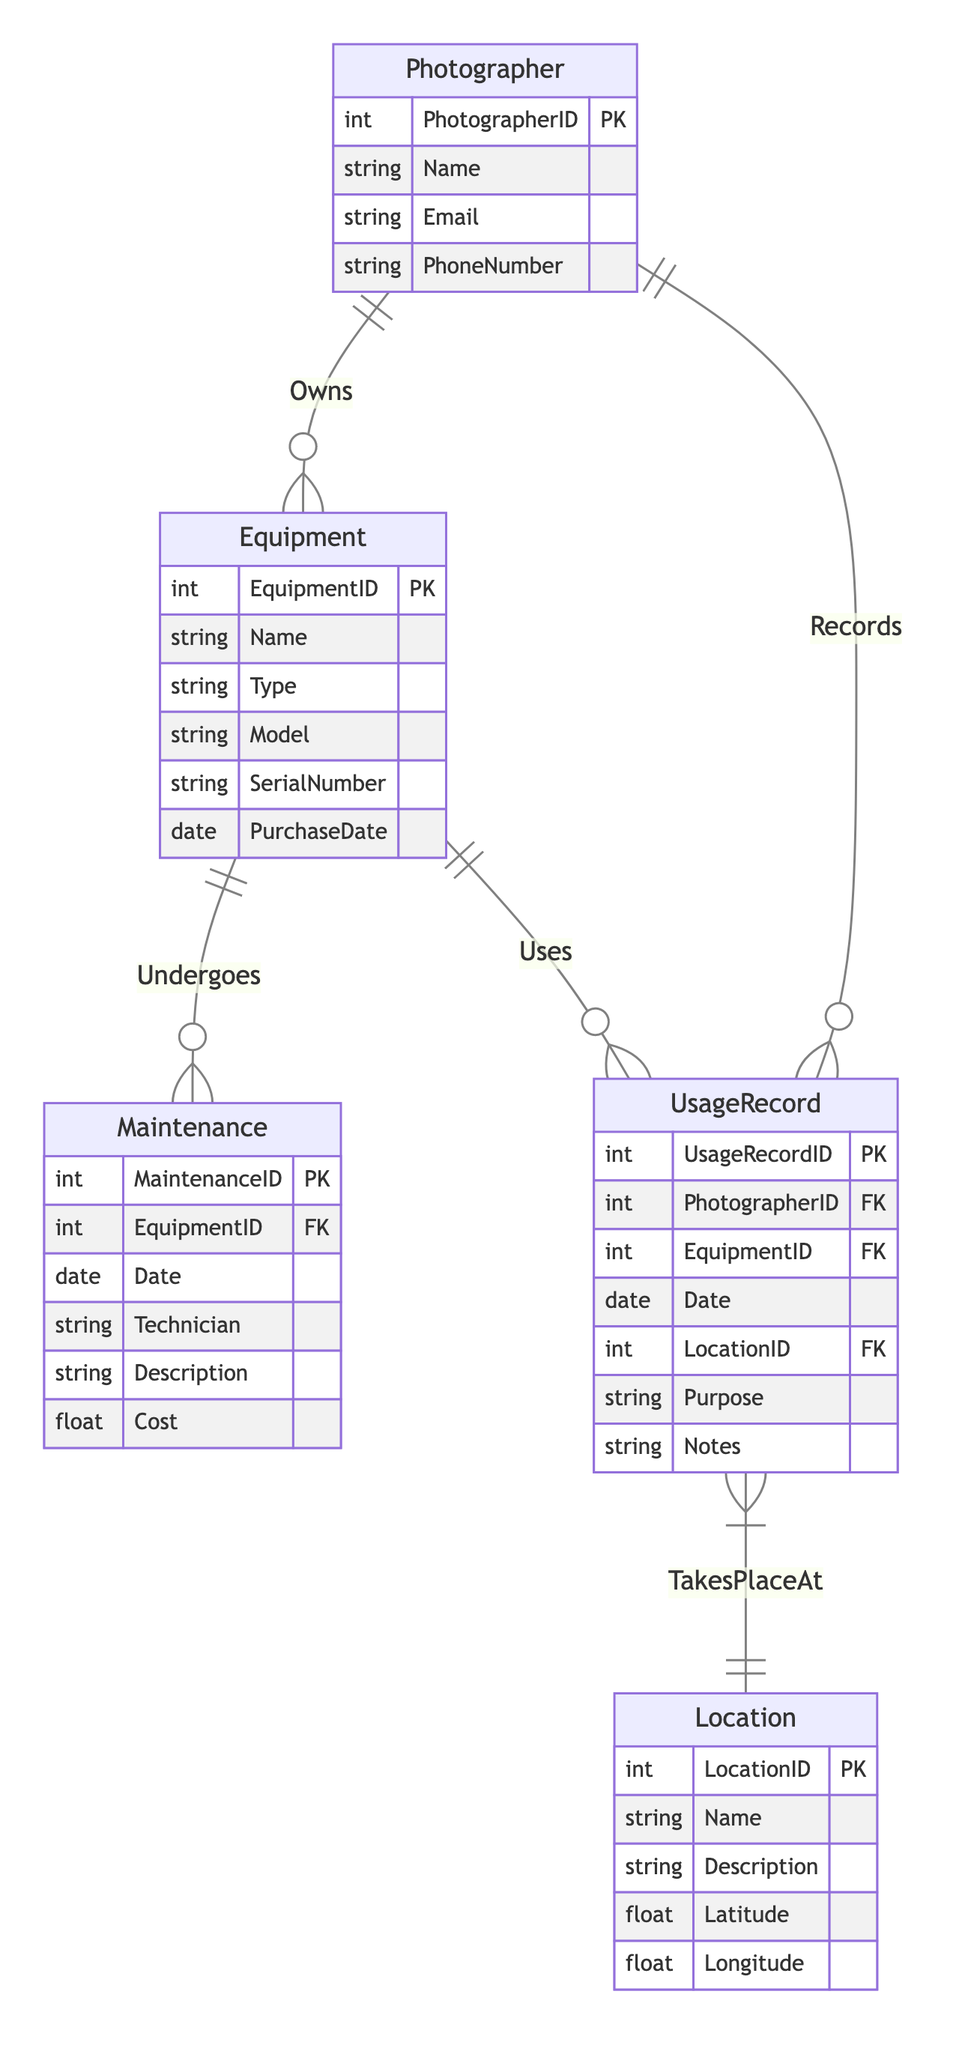What is the primary key of the Equipment entity? The primary key of the Equipment entity is EquipmentID, which is indicated by "PK" next to the attribute in the diagram.
Answer: EquipmentID How many relationships does the Photographer entity have? The Photographer entity has three relationships indicated in the diagram: Owns (with Equipment), Records (with UsageRecord), and Uses (with UsageRecord), totaling three relationships.
Answer: 3 What type of relationship exists between Equipment and Maintenance? The relationship between Equipment and Maintenance is "1:N," meaning that one piece of Equipment can undergo multiple Maintenance records. This is indicated in the diagram through the notation connecting the two entities.
Answer: 1:N How many total attributes does the Maintenance entity have? The Maintenance entity has six attributes, as listed in the diagram: MaintenanceID, EquipmentID, Date, Technician, Description, and Cost. Counting these gives a total of six attributes.
Answer: 6 What does the UsageRecord entity track in relation to the Photographer? The UsageRecord entity tracks the records made by the Photographer, including details such as Date, Purpose, and Notes. It reflects the relationship indicated by "Records" and serves to document usage details.
Answer: Records What is the cardinality of the relationship between UsageRecord and Location? The relationship between UsageRecord and Location is "1:N," signifying that one usage record can take place at one location, but one location can be associated with multiple usage records. This is shown by the notation in the diagram.
Answer: 1:N Which attribute in the UsageRecord entity identifies the purpose of using the equipment? The attribute that identifies the purpose of using the equipment in the UsageRecord entity is "Purpose," which is explicitly listed in the diagram alongside other attributes.
Answer: Purpose How many entities are connected directly to the Equipment entity? The Equipment entity is connected directly to two other entities: Maintenance (through the Undergoes relationship) and UsageRecord (through the Uses relationship), indicating its role in both maintenance and usage contexts.
Answer: 2 What attribute in the Location entity specifies its geographical position? The attributes that specify the geographical position in the Location entity are "Latitude" and "Longitude," both of which are included in the diagram to indicate location details.
Answer: Latitude, Longitude 